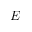<formula> <loc_0><loc_0><loc_500><loc_500>E</formula> 